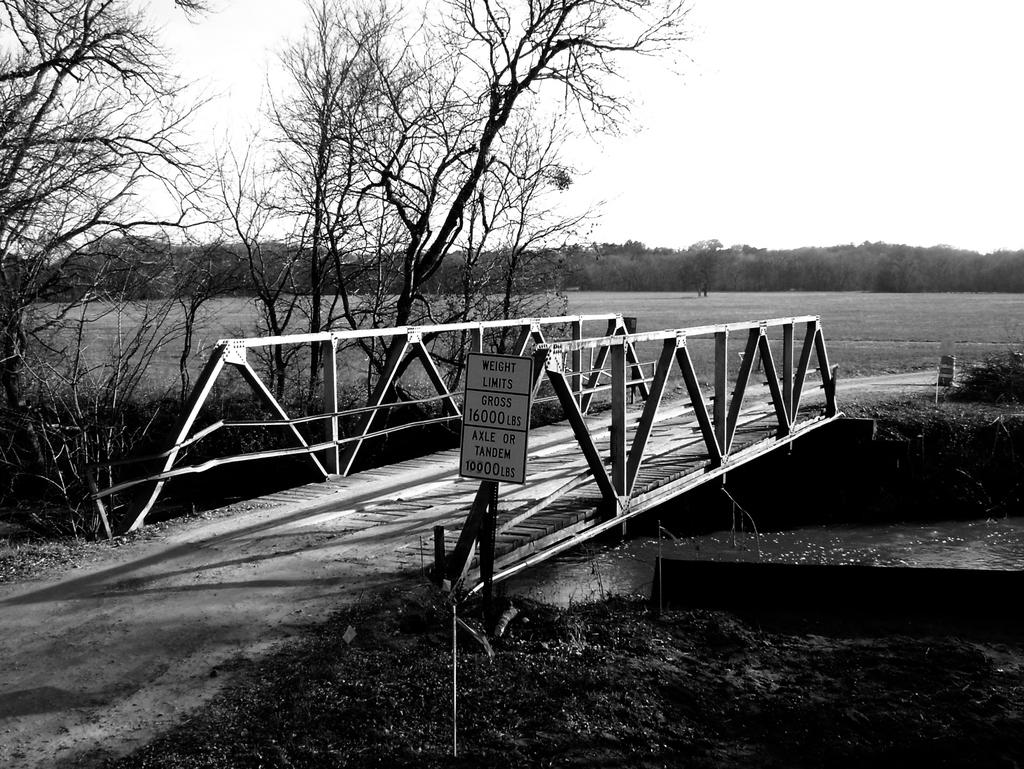What type of structure is in the picture? There is a wooden bridge in the picture. What safety measure is present on the bridge? The bridge has a precaution board. What can be seen below the bridge? There is a pond below the bridge. What type of vegetation is in the picture? There are trees and grass in the picture. What is the condition of the sky in the picture? The sky is clear in the picture. What type of sound can be heard coming from the volcano in the picture? There is no volcano present in the picture, so no such sound can be heard. How many spiders are visible on the bridge in the picture? There are no spiders visible on the bridge in the picture. 